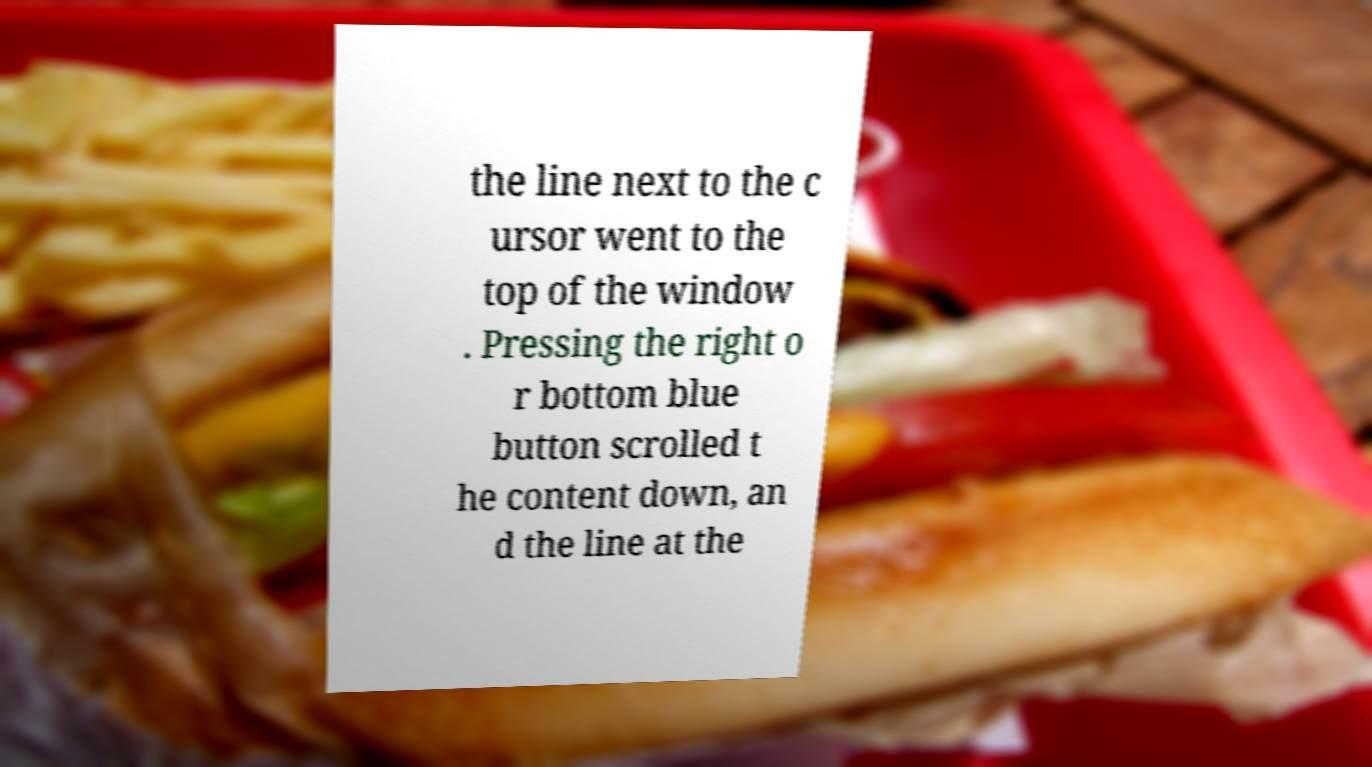Could you assist in decoding the text presented in this image and type it out clearly? the line next to the c ursor went to the top of the window . Pressing the right o r bottom blue button scrolled t he content down, an d the line at the 